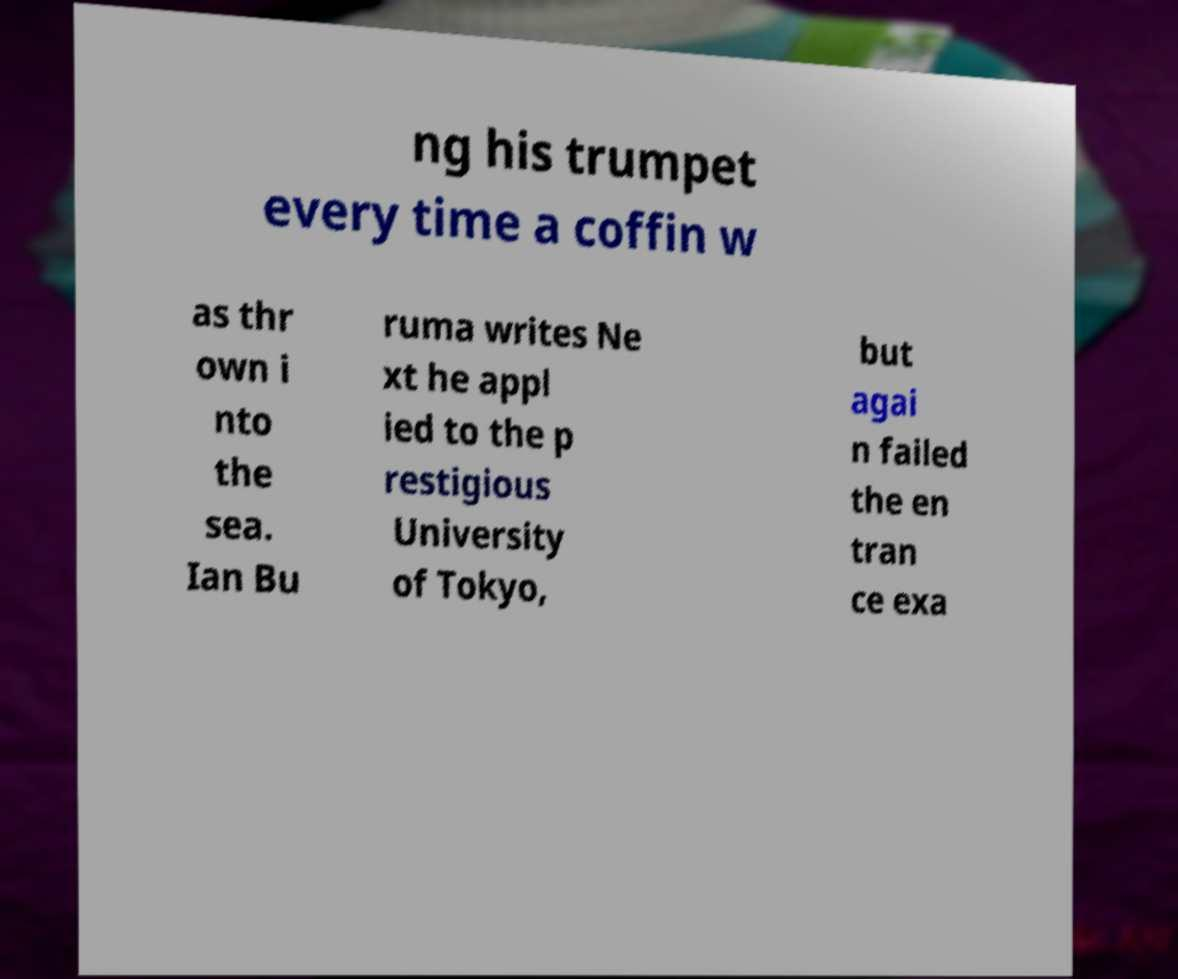Can you accurately transcribe the text from the provided image for me? ng his trumpet every time a coffin w as thr own i nto the sea. Ian Bu ruma writes Ne xt he appl ied to the p restigious University of Tokyo, but agai n failed the en tran ce exa 